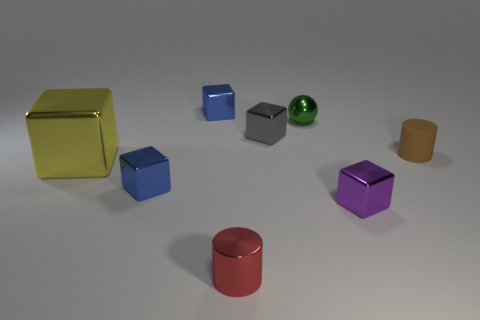Subtract all small purple metallic blocks. How many blocks are left? 4 Subtract all red cylinders. How many cylinders are left? 1 Subtract all cubes. How many objects are left? 3 Add 3 brown cylinders. How many brown cylinders are left? 4 Add 6 red things. How many red things exist? 7 Add 2 small cylinders. How many objects exist? 10 Subtract 0 purple cylinders. How many objects are left? 8 Subtract 1 cubes. How many cubes are left? 4 Subtract all red cylinders. Subtract all cyan cubes. How many cylinders are left? 1 Subtract all cyan blocks. How many blue spheres are left? 0 